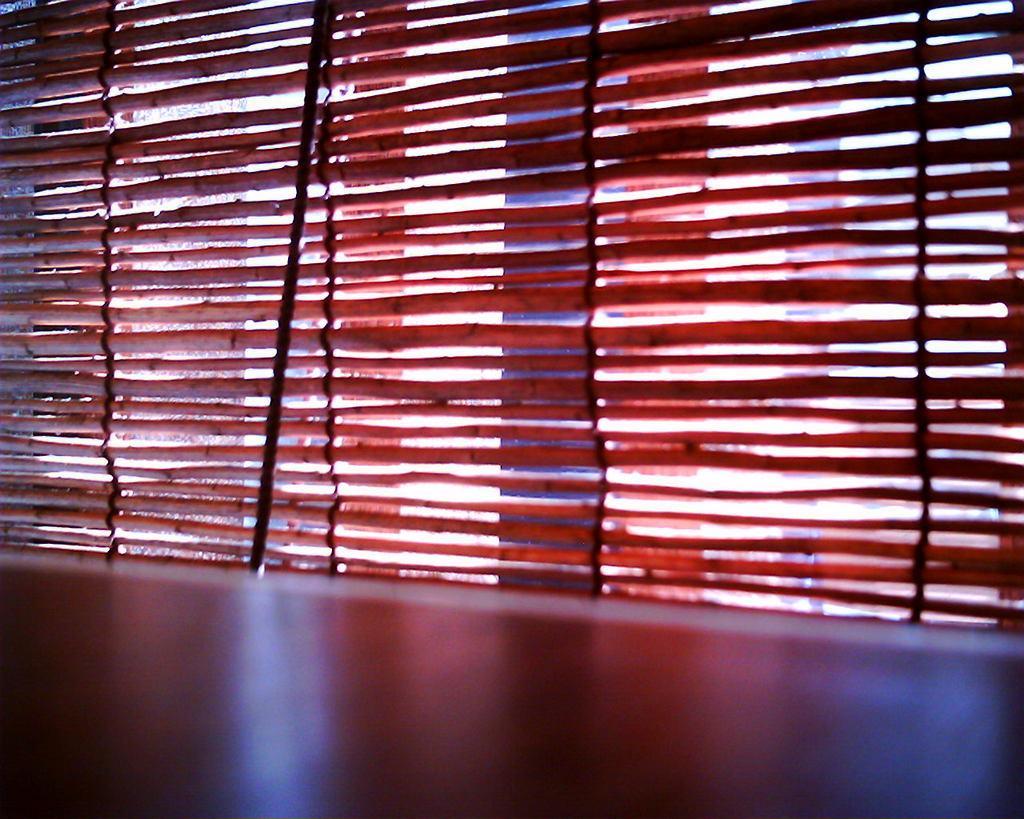Can you describe this image briefly? In this image we can see a wall and a bamboo curtain on a window. 